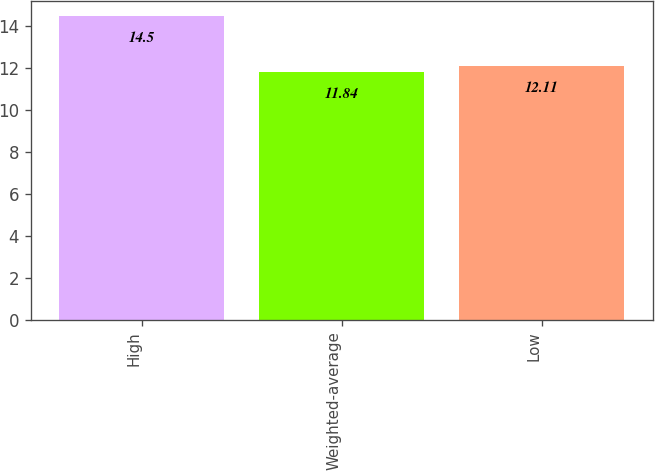Convert chart to OTSL. <chart><loc_0><loc_0><loc_500><loc_500><bar_chart><fcel>High<fcel>Weighted-average<fcel>Low<nl><fcel>14.5<fcel>11.84<fcel>12.11<nl></chart> 